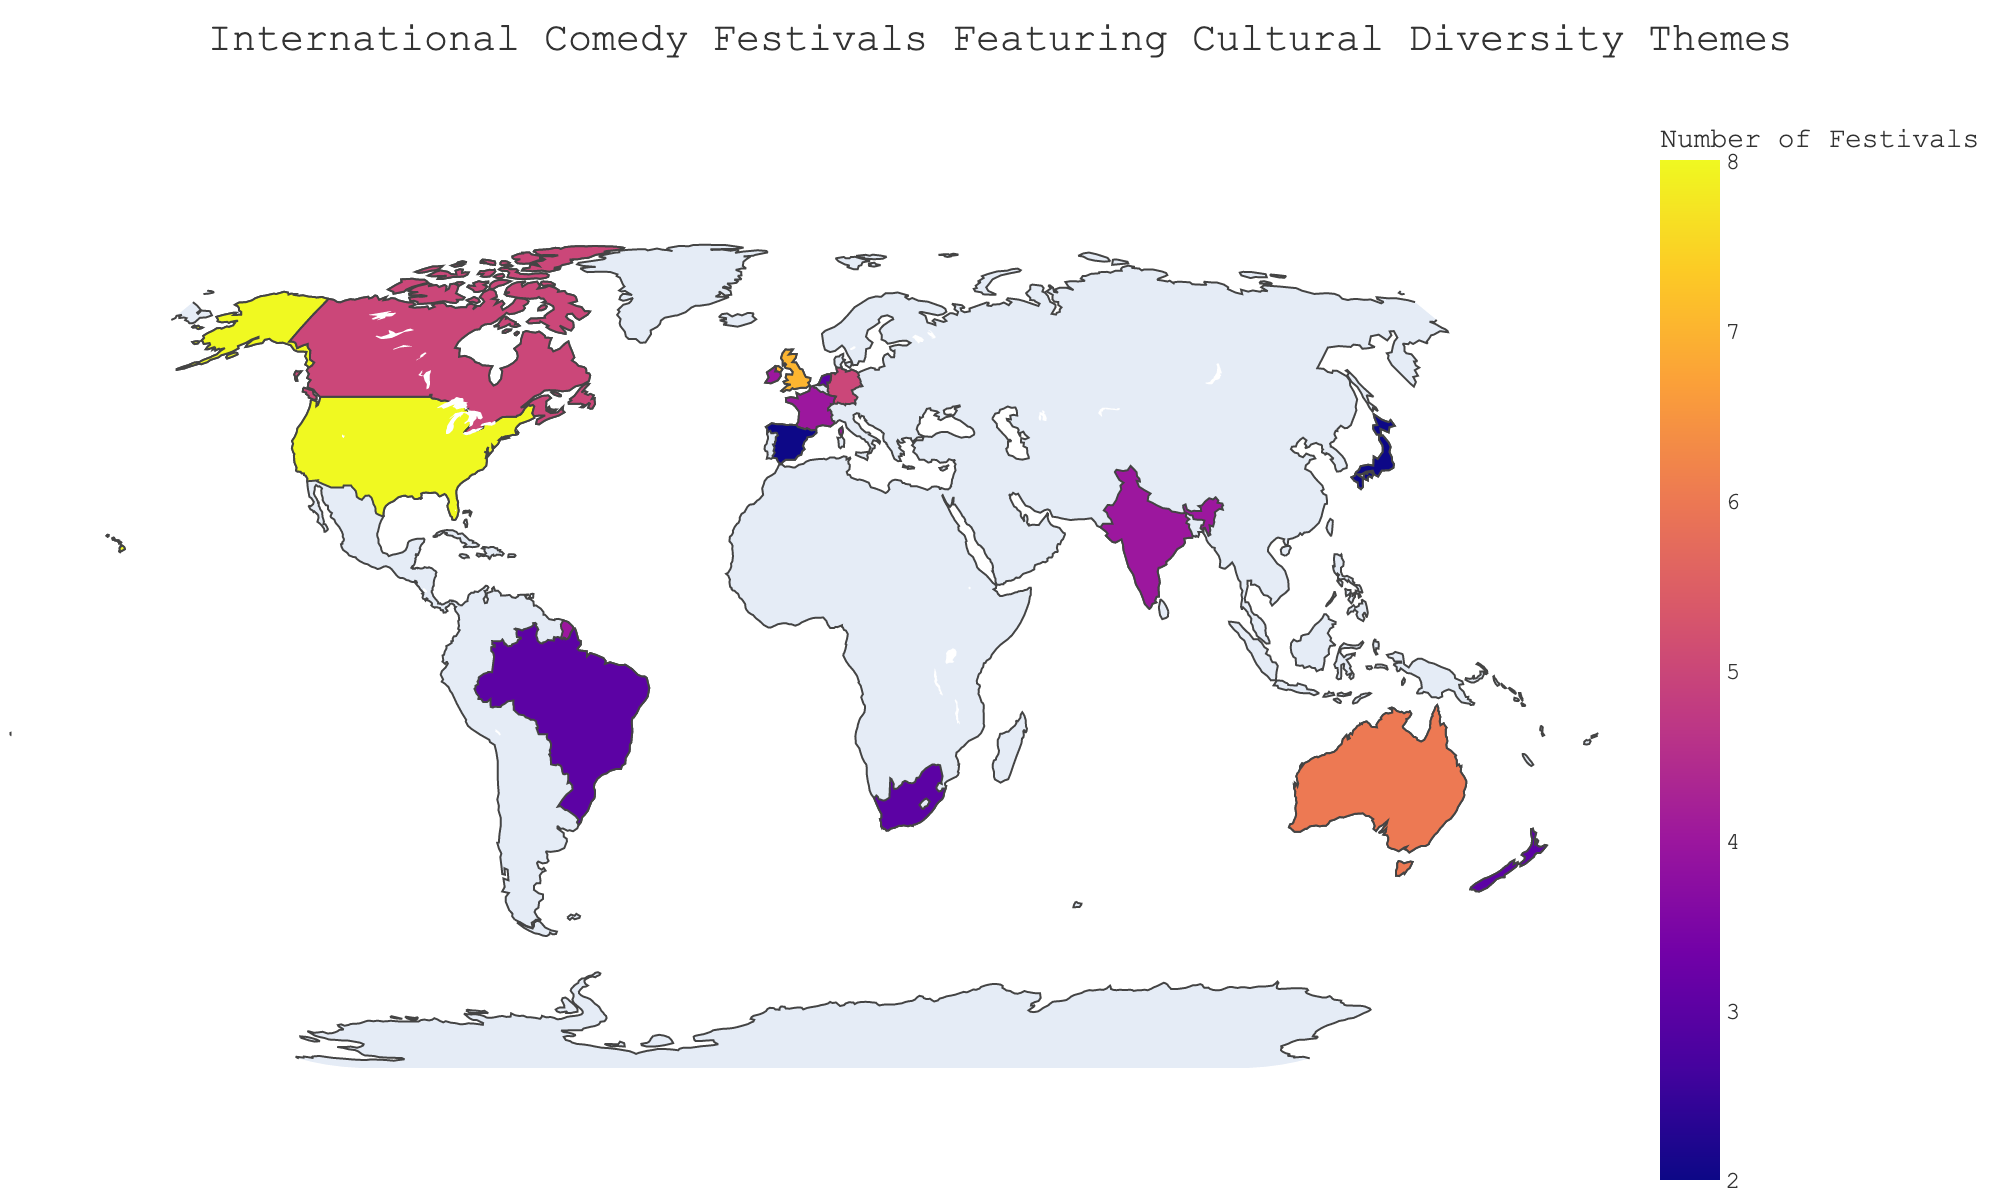Which country hosts the highest number of comedy festivals featuring cultural diversity themes? By looking at the color intensity on the map and the hover information, the country with the highest number of festivals is the United States.
Answer: United States Which countries have the same number of festivals as Germany? By comparing the "Festival_Count" for Germany, which is 5, you can see that Canada also has 5 festivals.
Answer: Canada How many festivals does Japan host? Hovering over Japan on the map shows that it hosts 2 festivals.
Answer: 2 Which countries have fewer than 3 festivals? By evaluating the festival counts, countries with fewer than 3 festivals are Japan and Singapore.
Answer: Japan, Singapore What's the total number of festivals hosted by Canada and Australia combined? Canada has 5 festivals and Australia has 6; adding these together gives 11.
Answer: 11 Among the listed countries, which one hosts exactly 4 festivals? Hovering over each country reveals that India, France, and Ireland each host 4 festivals.
Answer: India, France, Ireland Which country in Europe has the most festivals? European countries listed are the United Kingdom, Germany, France, Netherlands, and Spain. The United Kingdom has the most with 7 festivals.
Answer: United Kingdom How does the number of festivals in Brazil compare to New Zealand? Both Brazil and New Zealand are shown to have 3 festivals each.
Answer: Same (3) What is the range of the number of festivals hosted by the countries with the most and least festivals? The United States hosts the most festivals (8) and Japan/Singapore host the least (2). The range is 8 - 2, which equals 6.
Answer: 6 In total, how many festivals are hosted by all the listed countries? Summing all the festivals: 8 (United States) + 5 (Canada) + 7 (United Kingdom) + 6 (Australia) + 4 (India) + 3 (South Africa) + 5 (Germany) + 4 (France) + 3 (Netherlands) + 2 (Japan) + 3 (Brazil) + 2 (Singapore) + 4 (Ireland) + 3 (New Zealand) + 2 (Spain) = 59.
Answer: 59 